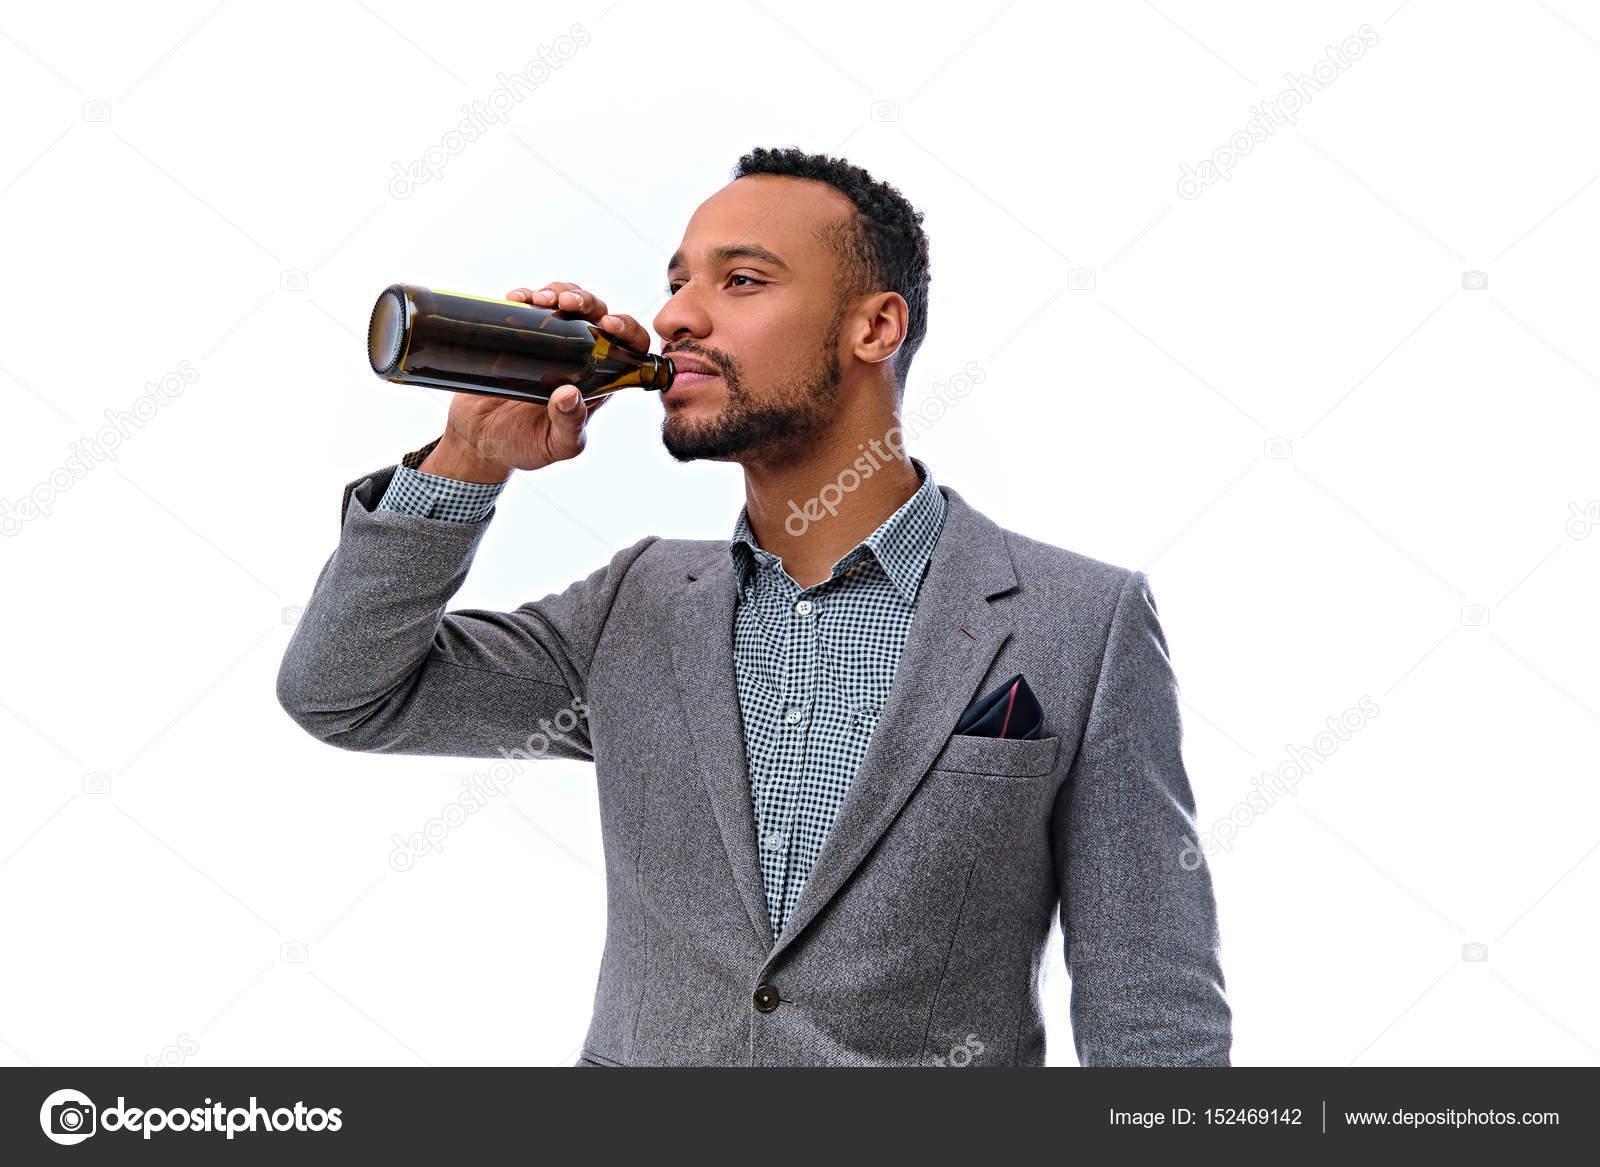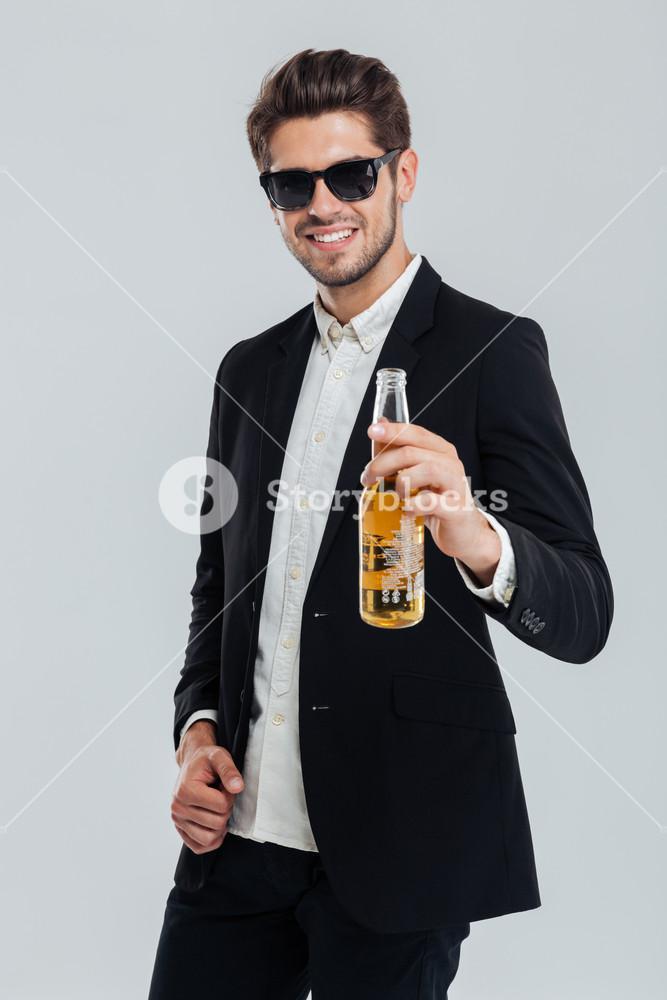The first image is the image on the left, the second image is the image on the right. Analyze the images presented: Is the assertion "The left and right image contains the same number of men standing drinking a single beer." valid? Answer yes or no. Yes. The first image is the image on the left, the second image is the image on the right. Evaluate the accuracy of this statement regarding the images: "One of these guys does not have a beer bottle at their lips.". Is it true? Answer yes or no. Yes. 